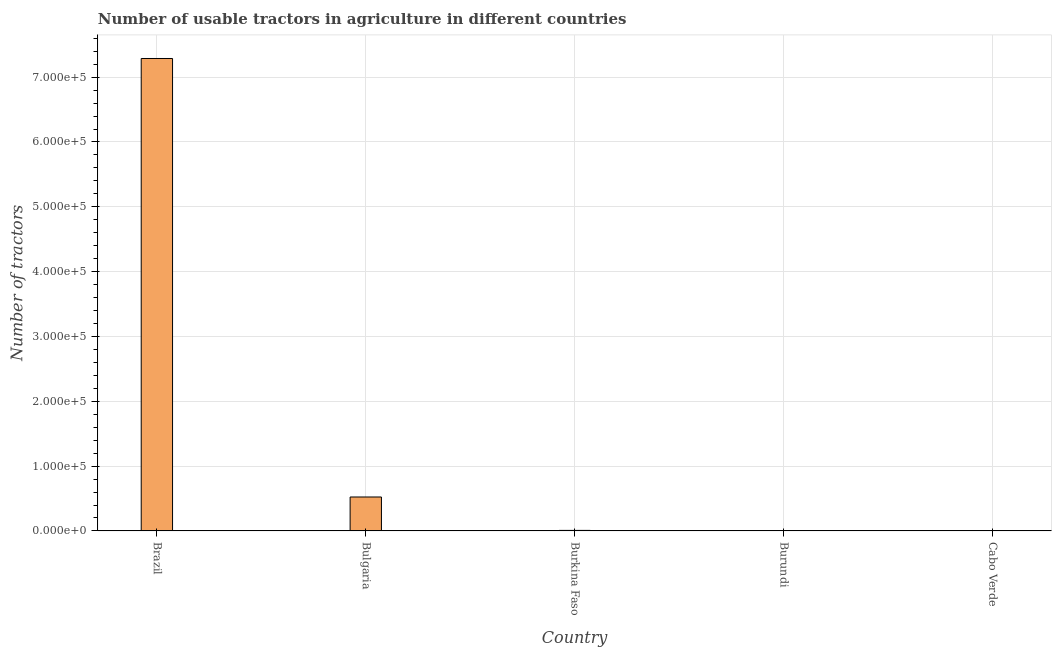Does the graph contain grids?
Keep it short and to the point. Yes. What is the title of the graph?
Provide a succinct answer. Number of usable tractors in agriculture in different countries. What is the label or title of the Y-axis?
Make the answer very short. Number of tractors. What is the number of tractors in Burkina Faso?
Offer a very short reply. 840. Across all countries, what is the maximum number of tractors?
Provide a short and direct response. 7.29e+05. Across all countries, what is the minimum number of tractors?
Keep it short and to the point. 29. In which country was the number of tractors minimum?
Make the answer very short. Cabo Verde. What is the sum of the number of tractors?
Offer a very short reply. 7.82e+05. What is the difference between the number of tractors in Bulgaria and Burkina Faso?
Offer a terse response. 5.15e+04. What is the average number of tractors per country?
Your answer should be compact. 1.56e+05. What is the median number of tractors?
Your response must be concise. 840. In how many countries, is the number of tractors greater than 460000 ?
Make the answer very short. 1. What is the ratio of the number of tractors in Bulgaria to that in Cabo Verde?
Your answer should be compact. 1806.03. What is the difference between the highest and the second highest number of tractors?
Offer a terse response. 6.76e+05. What is the difference between the highest and the lowest number of tractors?
Offer a very short reply. 7.29e+05. What is the difference between two consecutive major ticks on the Y-axis?
Your answer should be compact. 1.00e+05. What is the Number of tractors of Brazil?
Make the answer very short. 7.29e+05. What is the Number of tractors in Bulgaria?
Provide a short and direct response. 5.24e+04. What is the Number of tractors in Burkina Faso?
Offer a very short reply. 840. What is the Number of tractors in Burundi?
Give a very brief answer. 163. What is the Number of tractors of Cabo Verde?
Your response must be concise. 29. What is the difference between the Number of tractors in Brazil and Bulgaria?
Make the answer very short. 6.76e+05. What is the difference between the Number of tractors in Brazil and Burkina Faso?
Keep it short and to the point. 7.28e+05. What is the difference between the Number of tractors in Brazil and Burundi?
Ensure brevity in your answer.  7.29e+05. What is the difference between the Number of tractors in Brazil and Cabo Verde?
Your answer should be very brief. 7.29e+05. What is the difference between the Number of tractors in Bulgaria and Burkina Faso?
Your response must be concise. 5.15e+04. What is the difference between the Number of tractors in Bulgaria and Burundi?
Your response must be concise. 5.22e+04. What is the difference between the Number of tractors in Bulgaria and Cabo Verde?
Your response must be concise. 5.23e+04. What is the difference between the Number of tractors in Burkina Faso and Burundi?
Offer a terse response. 677. What is the difference between the Number of tractors in Burkina Faso and Cabo Verde?
Keep it short and to the point. 811. What is the difference between the Number of tractors in Burundi and Cabo Verde?
Ensure brevity in your answer.  134. What is the ratio of the Number of tractors in Brazil to that in Bulgaria?
Offer a terse response. 13.91. What is the ratio of the Number of tractors in Brazil to that in Burkina Faso?
Provide a succinct answer. 867.59. What is the ratio of the Number of tractors in Brazil to that in Burundi?
Offer a terse response. 4471.04. What is the ratio of the Number of tractors in Brazil to that in Cabo Verde?
Give a very brief answer. 2.51e+04. What is the ratio of the Number of tractors in Bulgaria to that in Burkina Faso?
Your answer should be very brief. 62.35. What is the ratio of the Number of tractors in Bulgaria to that in Burundi?
Give a very brief answer. 321.32. What is the ratio of the Number of tractors in Bulgaria to that in Cabo Verde?
Offer a very short reply. 1806.03. What is the ratio of the Number of tractors in Burkina Faso to that in Burundi?
Ensure brevity in your answer.  5.15. What is the ratio of the Number of tractors in Burkina Faso to that in Cabo Verde?
Ensure brevity in your answer.  28.97. What is the ratio of the Number of tractors in Burundi to that in Cabo Verde?
Offer a very short reply. 5.62. 